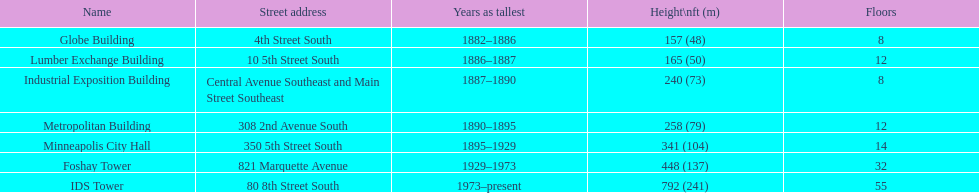How many floors does the foshay tower have? 32. 